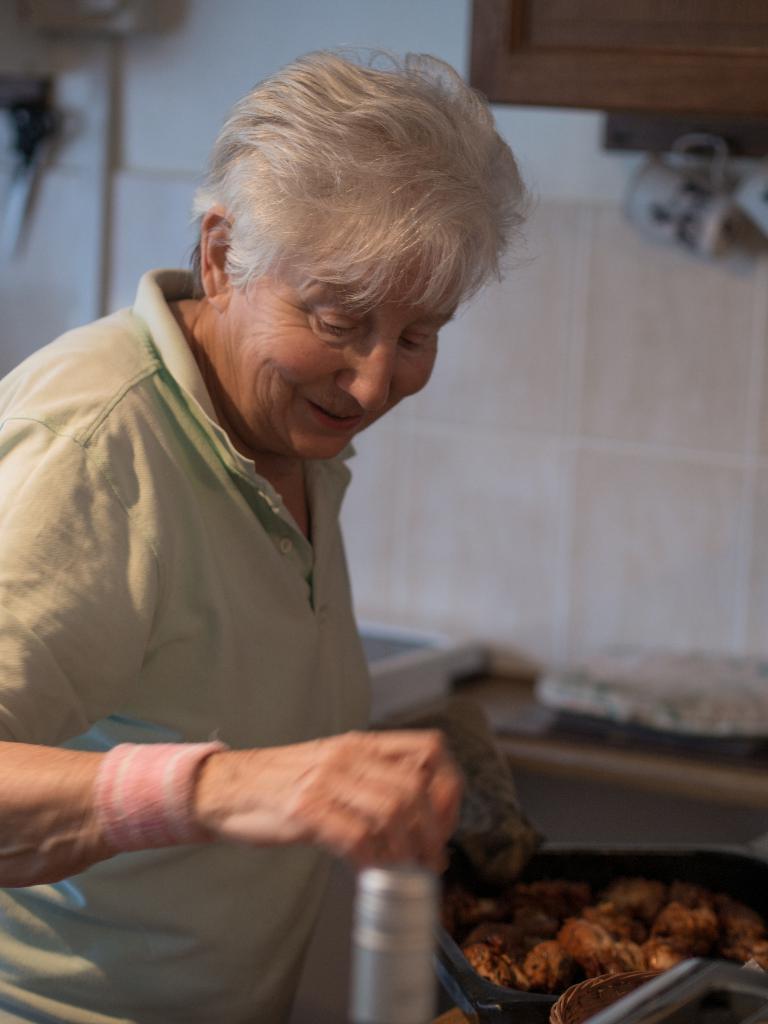Please provide a concise description of this image. In the image there is a person and in front of the person there are some food items and the person is holding a bottle, the background of the person is blur. 